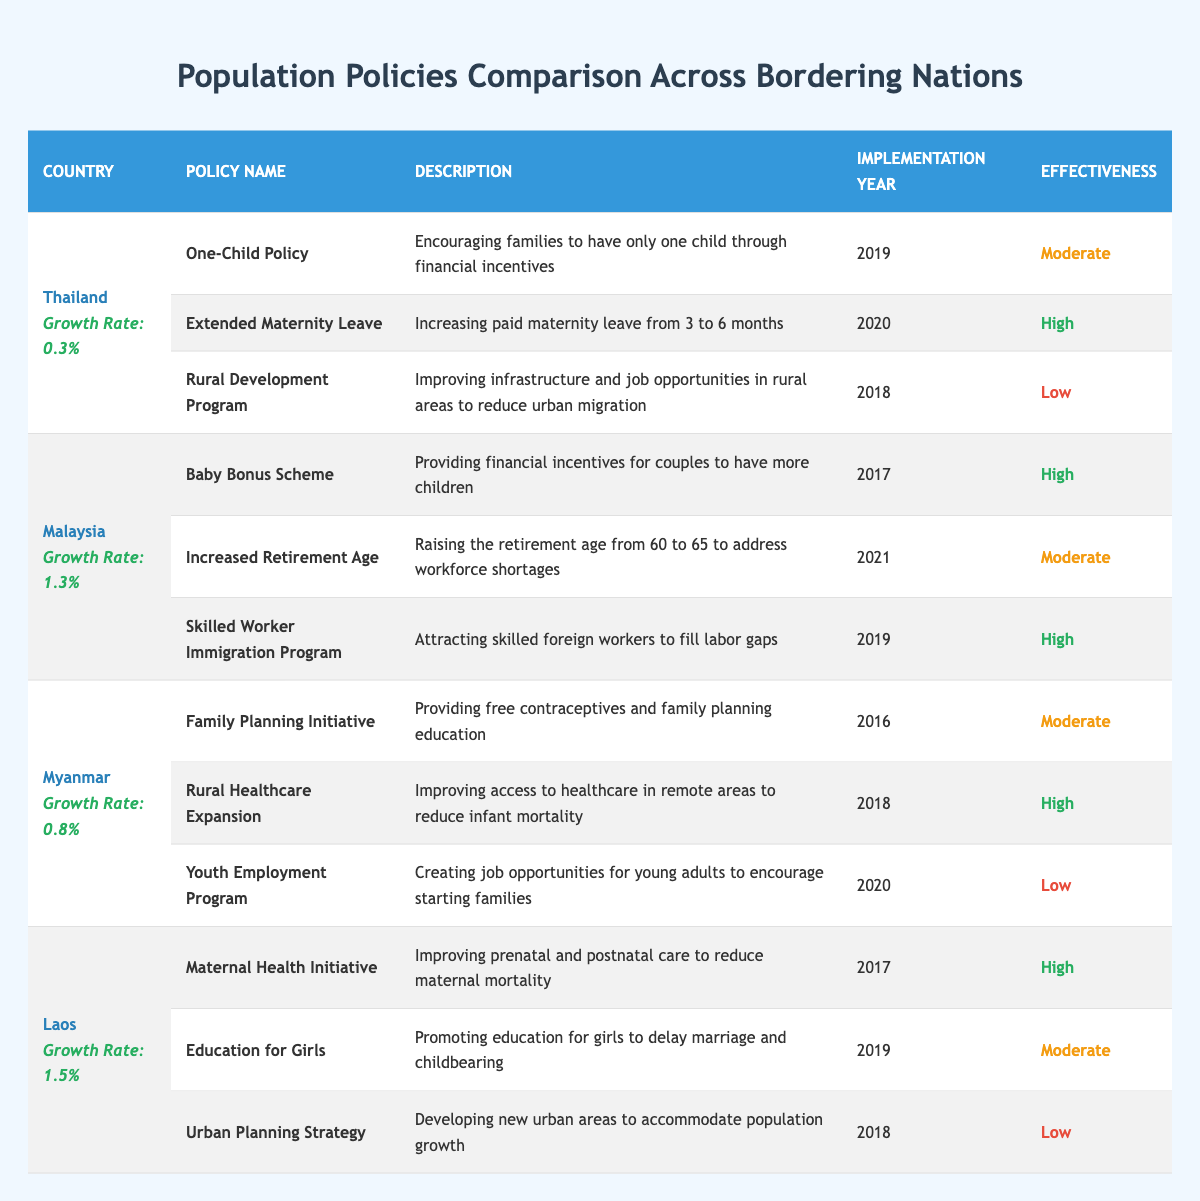What is the population growth rate of Laos? The population growth rate of Laos is listed in the table next to the country's name. It shows "Growth Rate: 1.5%".
Answer: 1.5% Which country has the highest population growth rate? By comparing the growth rates from the table, Malaysia has a growth rate of 1.3%, Myanmar has 0.8%, Thailand has 0.3%, and Laos has 1.5%. Therefore, Laos has the highest growth rate among them.
Answer: Laos How many policies does Thailand have listed in the table? The table includes three policies for Thailand, which are the One-Child Policy, Extended Maternity Leave, and the Rural Development Program.
Answer: 3 What year was the Baby Bonus Scheme implemented in Malaysia? Referring to the table, the Baby Bonus Scheme has the implementation year stated as 2017 in the corresponding row for Malaysia.
Answer: 2017 Is the effectiveness of the Rural Healthcare Expansion in Myanmar rated as high? Looking at the table for the Rural Healthcare Expansion policy, the effectiveness is labeled as "High", confirming that it is rated high.
Answer: Yes Which country implemented a policy to encourage families to have only one child? The table indicates that Thailand has the One-Child Policy aimed at encouraging families to have a single child through financial incentives.
Answer: Thailand Calculate the average effectiveness rating of the policies implemented by Laos. The effectiveness ratings for Laos' policies are: Maternal Health Initiative (High), Education for Girls (Moderate), Urban Planning Strategy (Low). Converting these to numerical values: High=2, Moderate=1, Low=0, the sum is (2 + 1 + 0) = 3. There are 3 policies, so the average effectiveness is 3/3 = 1.
Answer: 1 Does any country other than Malaysia have a policy aimed at skilled foreign workers? By checking the table, Malaysia's Skilled Worker Immigration Program is the only explicitly mentioned policy aimed at skilled foreign workers, and no other country has a similar program listed.
Answer: No What effectiveness rating is associated with Thailand's Extended Maternity Leave policy? The table shows that the effectiveness rating for Thailand's Extended Maternity Leave policy is listed as "High".
Answer: High 